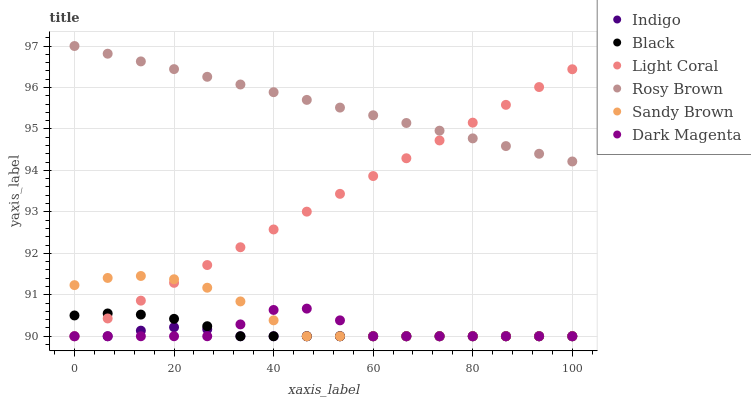Does Indigo have the minimum area under the curve?
Answer yes or no. Yes. Does Rosy Brown have the maximum area under the curve?
Answer yes or no. Yes. Does Dark Magenta have the minimum area under the curve?
Answer yes or no. No. Does Dark Magenta have the maximum area under the curve?
Answer yes or no. No. Is Rosy Brown the smoothest?
Answer yes or no. Yes. Is Dark Magenta the roughest?
Answer yes or no. Yes. Is Dark Magenta the smoothest?
Answer yes or no. No. Is Rosy Brown the roughest?
Answer yes or no. No. Does Indigo have the lowest value?
Answer yes or no. Yes. Does Rosy Brown have the lowest value?
Answer yes or no. No. Does Rosy Brown have the highest value?
Answer yes or no. Yes. Does Dark Magenta have the highest value?
Answer yes or no. No. Is Indigo less than Rosy Brown?
Answer yes or no. Yes. Is Rosy Brown greater than Dark Magenta?
Answer yes or no. Yes. Does Indigo intersect Black?
Answer yes or no. Yes. Is Indigo less than Black?
Answer yes or no. No. Is Indigo greater than Black?
Answer yes or no. No. Does Indigo intersect Rosy Brown?
Answer yes or no. No. 